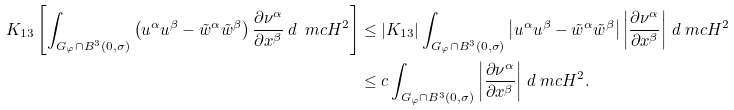Convert formula to latex. <formula><loc_0><loc_0><loc_500><loc_500>K _ { 1 3 } \left [ \int _ { G _ { \varphi } \cap B ^ { 3 } ( 0 , \sigma ) } \left ( u ^ { \alpha } u ^ { \beta } - \tilde { w } ^ { \alpha } \tilde { w } ^ { \beta } \right ) \frac { \partial \nu ^ { \alpha } } { \partial x ^ { \beta } } \, d \ m c H ^ { 2 } \right ] & \leq | K _ { 1 3 } | \int _ { G _ { \varphi } \cap B ^ { 3 } ( 0 , \sigma ) } \left | u ^ { \alpha } u ^ { \beta } - \tilde { w } ^ { \alpha } \tilde { w } ^ { \beta } \right | \left | \frac { \partial \nu ^ { \alpha } } { \partial x ^ { \beta } } \right | \, d \ m c H ^ { 2 } \\ & \leq c \int _ { G _ { \varphi } \cap B ^ { 3 } ( 0 , \sigma ) } \left | \frac { \partial \nu ^ { \alpha } } { \partial x ^ { \beta } } \right | \, d \ m c H ^ { 2 } .</formula> 